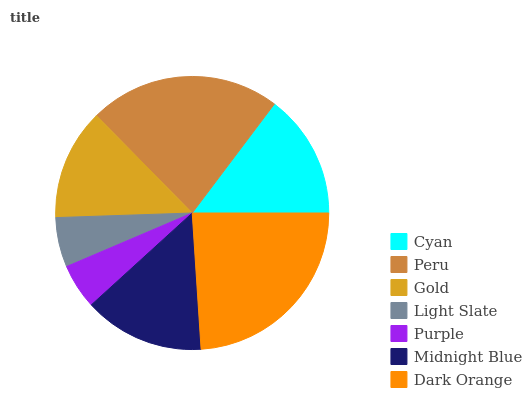Is Purple the minimum?
Answer yes or no. Yes. Is Dark Orange the maximum?
Answer yes or no. Yes. Is Peru the minimum?
Answer yes or no. No. Is Peru the maximum?
Answer yes or no. No. Is Peru greater than Cyan?
Answer yes or no. Yes. Is Cyan less than Peru?
Answer yes or no. Yes. Is Cyan greater than Peru?
Answer yes or no. No. Is Peru less than Cyan?
Answer yes or no. No. Is Midnight Blue the high median?
Answer yes or no. Yes. Is Midnight Blue the low median?
Answer yes or no. Yes. Is Light Slate the high median?
Answer yes or no. No. Is Purple the low median?
Answer yes or no. No. 